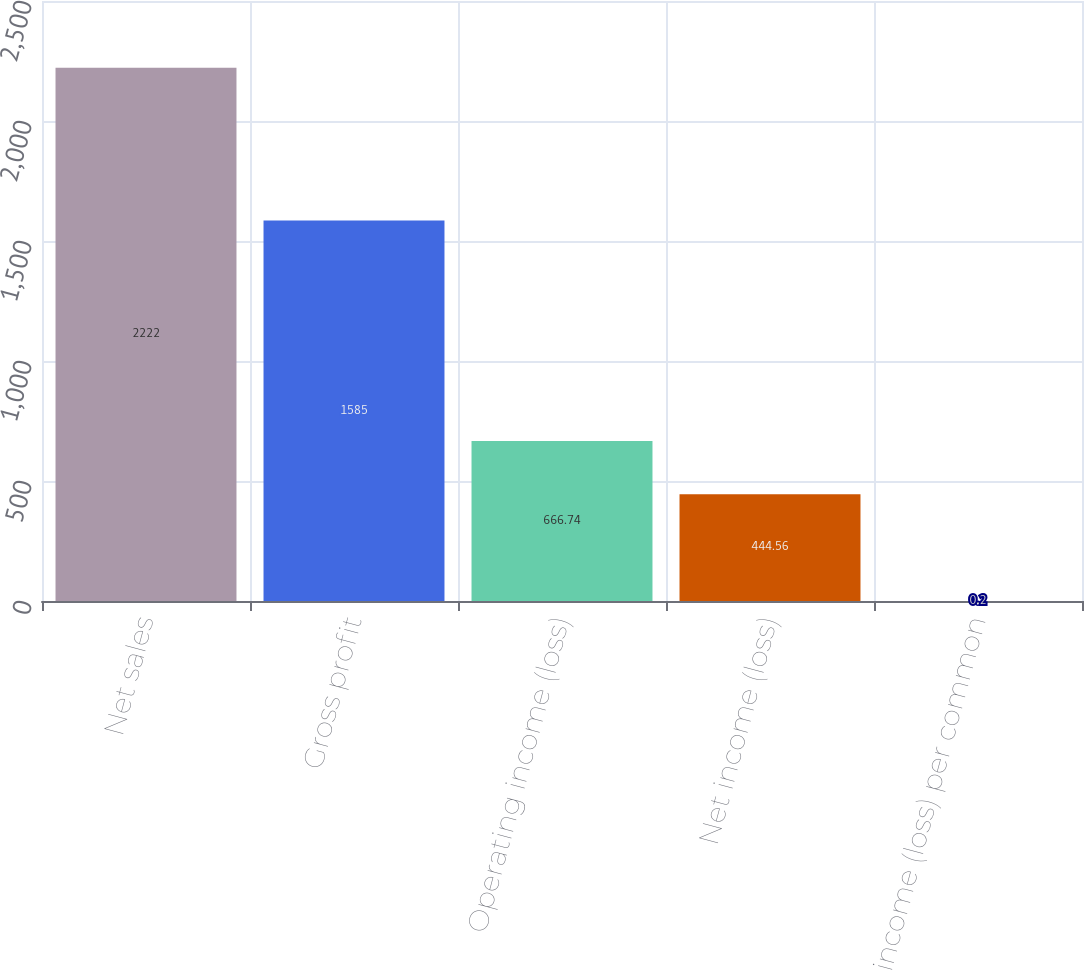Convert chart to OTSL. <chart><loc_0><loc_0><loc_500><loc_500><bar_chart><fcel>Net sales<fcel>Gross profit<fcel>Operating income (loss)<fcel>Net income (loss)<fcel>Net income (loss) per common<nl><fcel>2222<fcel>1585<fcel>666.74<fcel>444.56<fcel>0.2<nl></chart> 